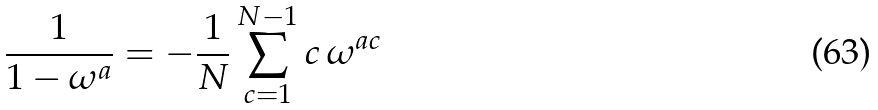Convert formula to latex. <formula><loc_0><loc_0><loc_500><loc_500>\frac { 1 } { 1 - \omega ^ { a } } = - \frac { 1 } { N } \sum _ { c = 1 } ^ { N - 1 } c \, \omega ^ { a c }</formula> 